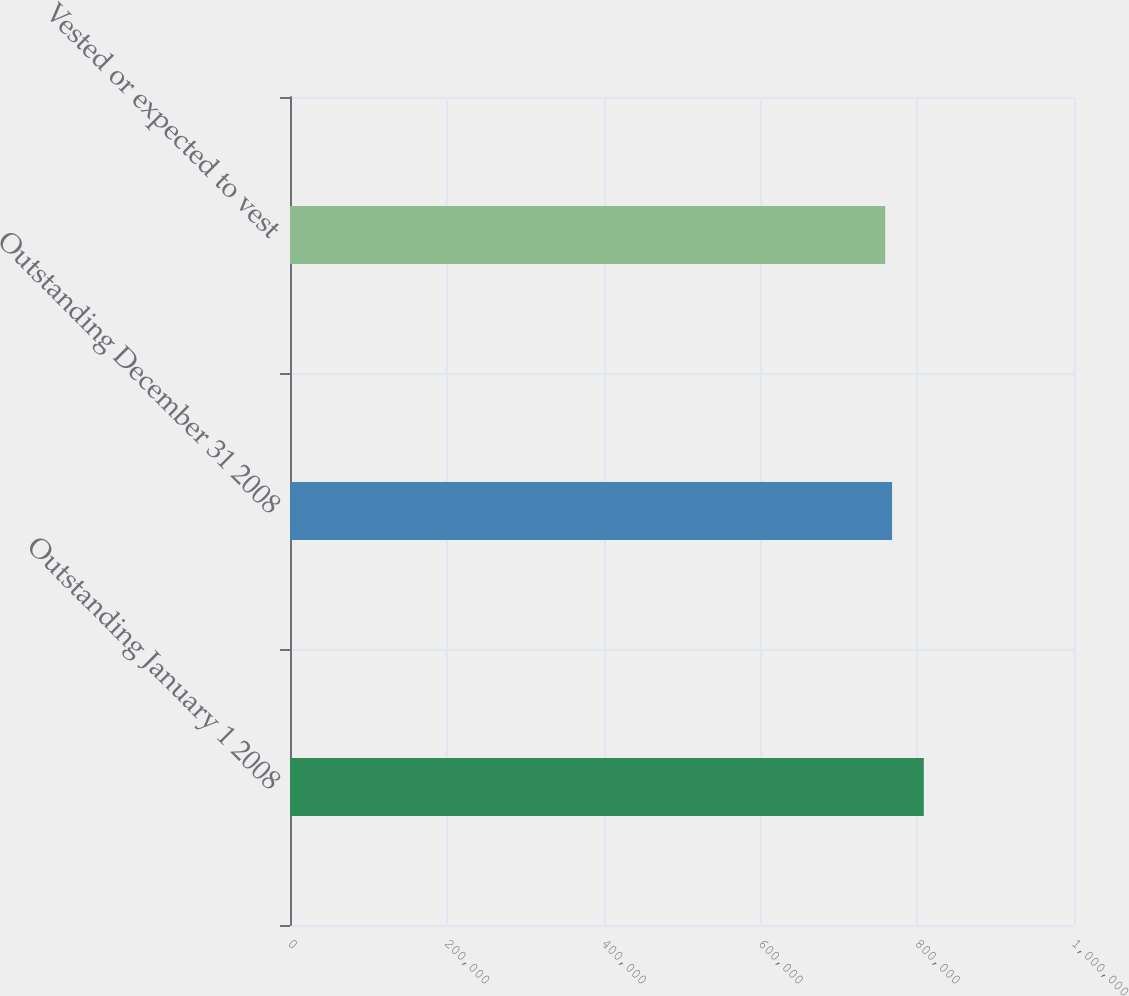Convert chart to OTSL. <chart><loc_0><loc_0><loc_500><loc_500><bar_chart><fcel>Outstanding January 1 2008<fcel>Outstanding December 31 2008<fcel>Vested or expected to vest<nl><fcel>808413<fcel>767940<fcel>759197<nl></chart> 